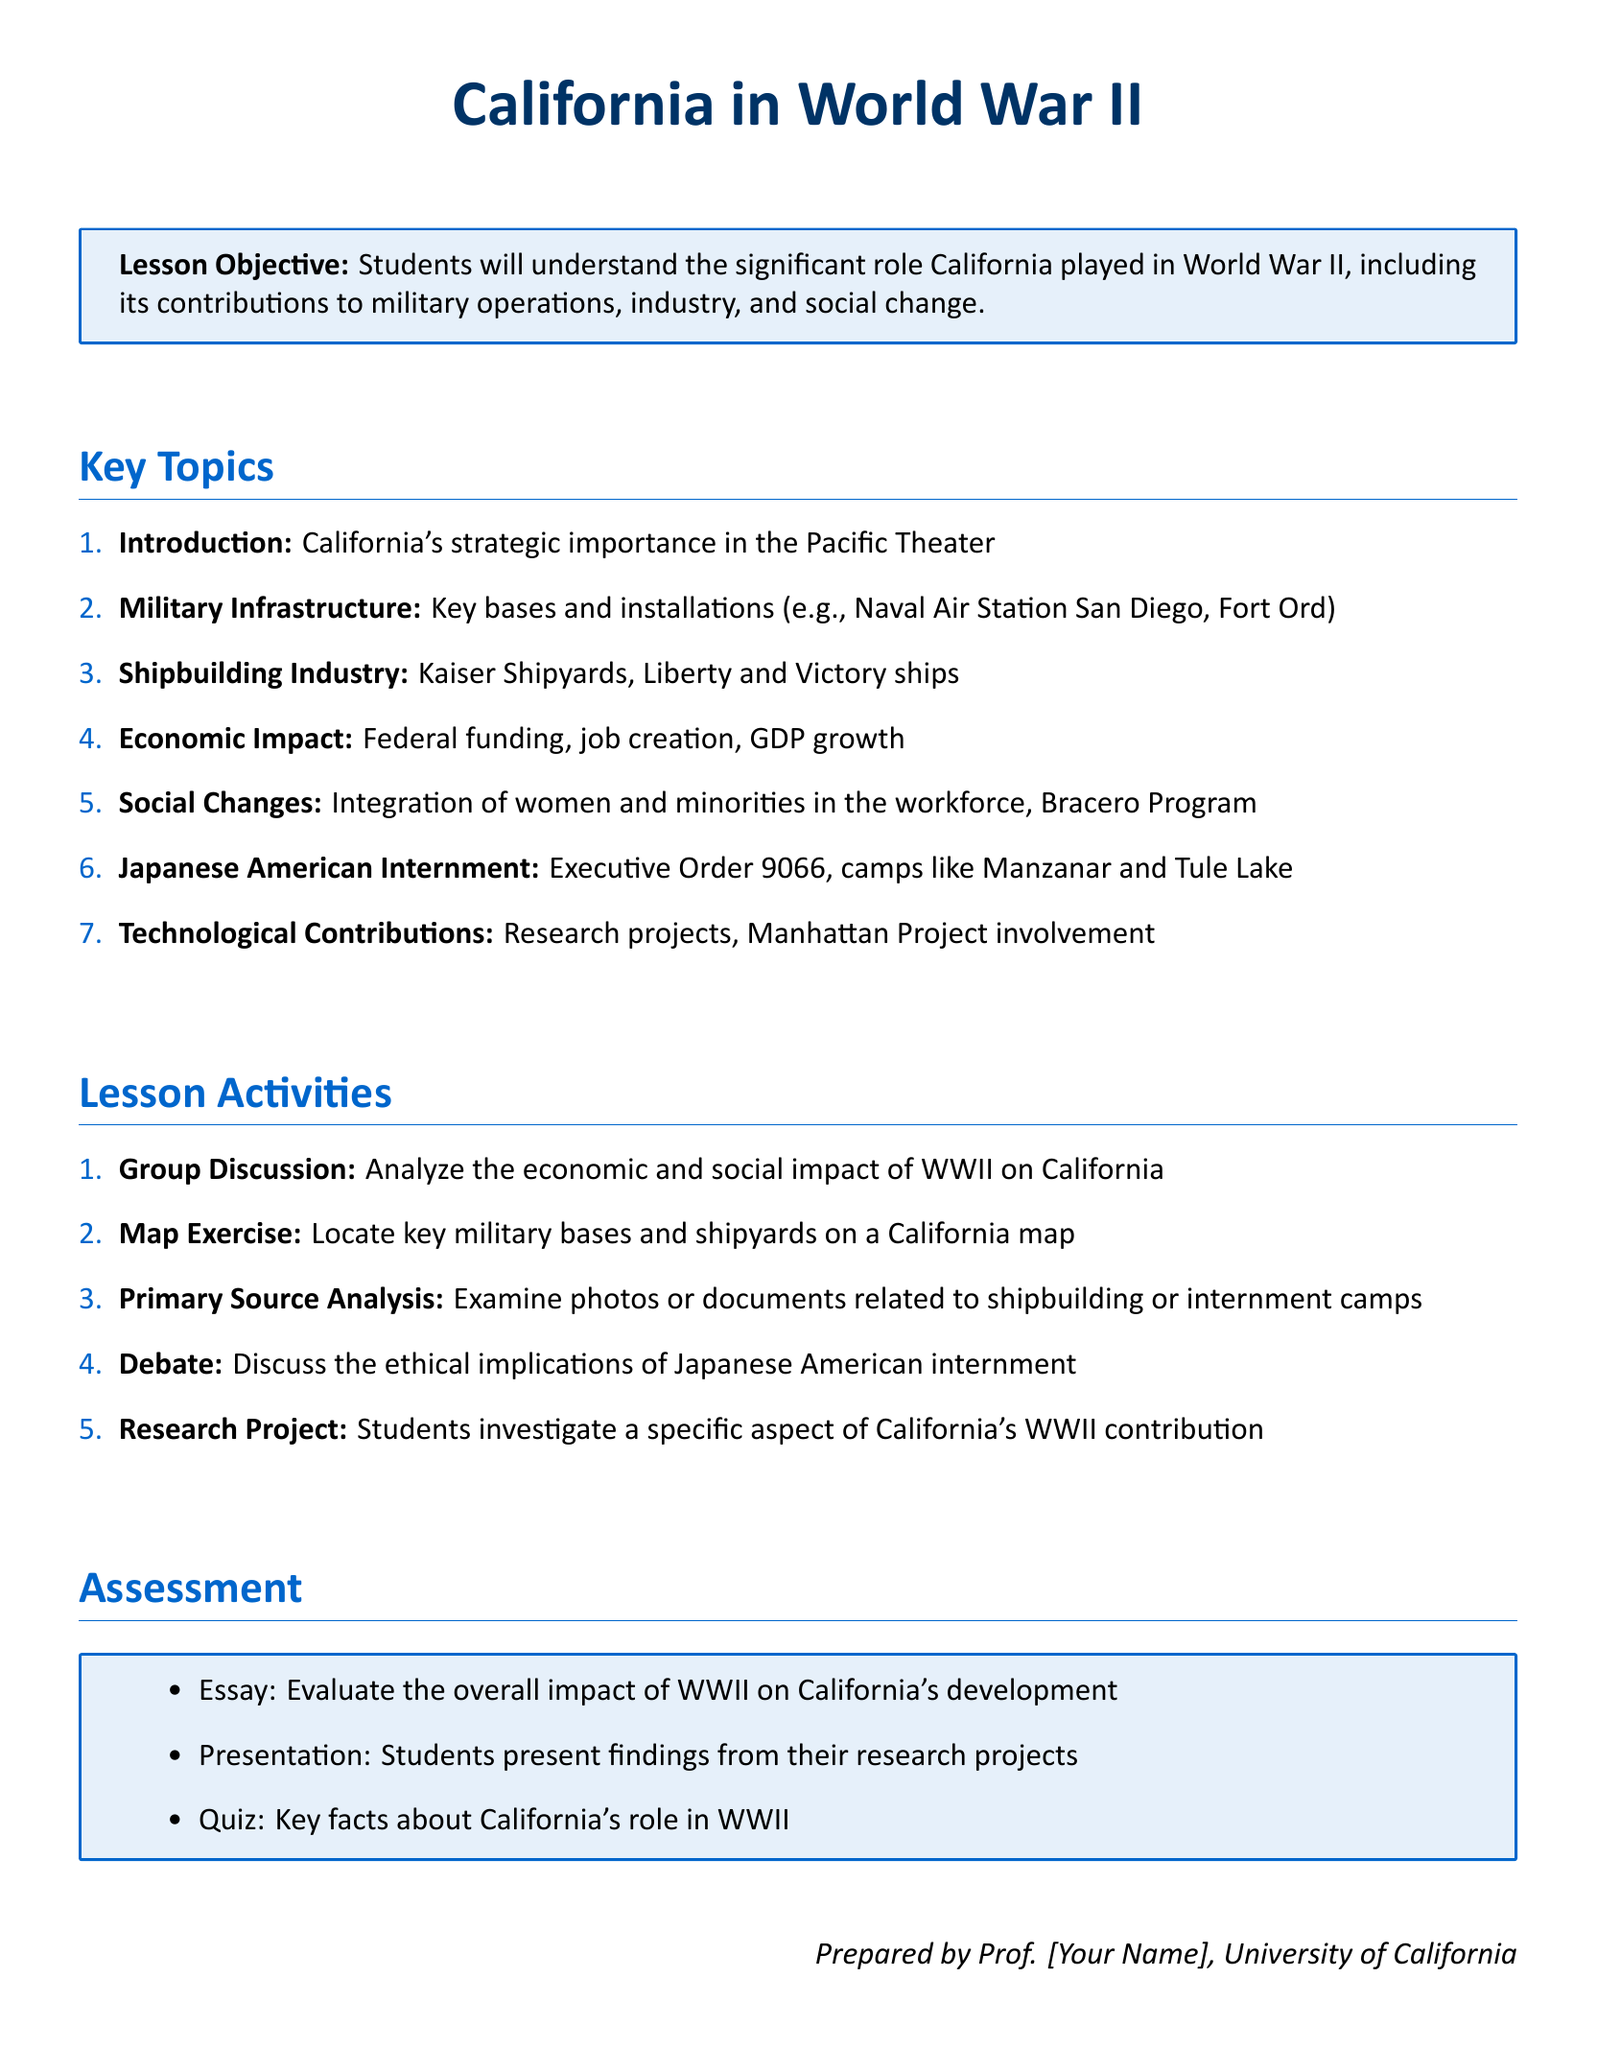What is the title of the lesson plan? The title of the lesson plan is prominently displayed at the beginning of the document.
Answer: California in World War II What is one key military base mentioned? The lesson plan lists specific military installations as part of its key topics.
Answer: Naval Air Station San Diego What program is mentioned that involved labor from Mexico? The document discusses social changes during the war, including a specific labor program.
Answer: Bracero Program What is one of the assessment methods used in the lesson plan? The assessment section outlines different methods for evaluating students’ understanding of the material.
Answer: Essay How many key topics are listed in the document? The total number of items under the Key Topics section indicates the range of areas covered.
Answer: Seven 